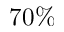Convert formula to latex. <formula><loc_0><loc_0><loc_500><loc_500>7 0 \%</formula> 